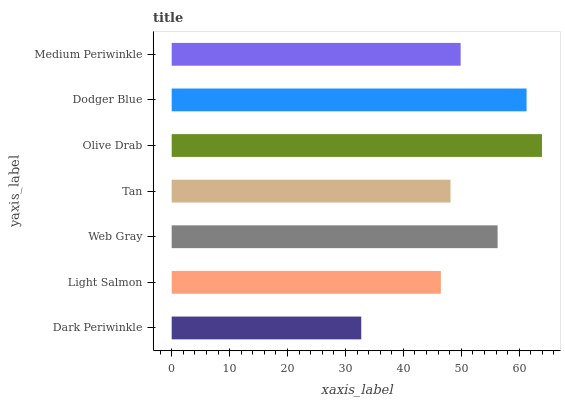Is Dark Periwinkle the minimum?
Answer yes or no. Yes. Is Olive Drab the maximum?
Answer yes or no. Yes. Is Light Salmon the minimum?
Answer yes or no. No. Is Light Salmon the maximum?
Answer yes or no. No. Is Light Salmon greater than Dark Periwinkle?
Answer yes or no. Yes. Is Dark Periwinkle less than Light Salmon?
Answer yes or no. Yes. Is Dark Periwinkle greater than Light Salmon?
Answer yes or no. No. Is Light Salmon less than Dark Periwinkle?
Answer yes or no. No. Is Medium Periwinkle the high median?
Answer yes or no. Yes. Is Medium Periwinkle the low median?
Answer yes or no. Yes. Is Light Salmon the high median?
Answer yes or no. No. Is Tan the low median?
Answer yes or no. No. 